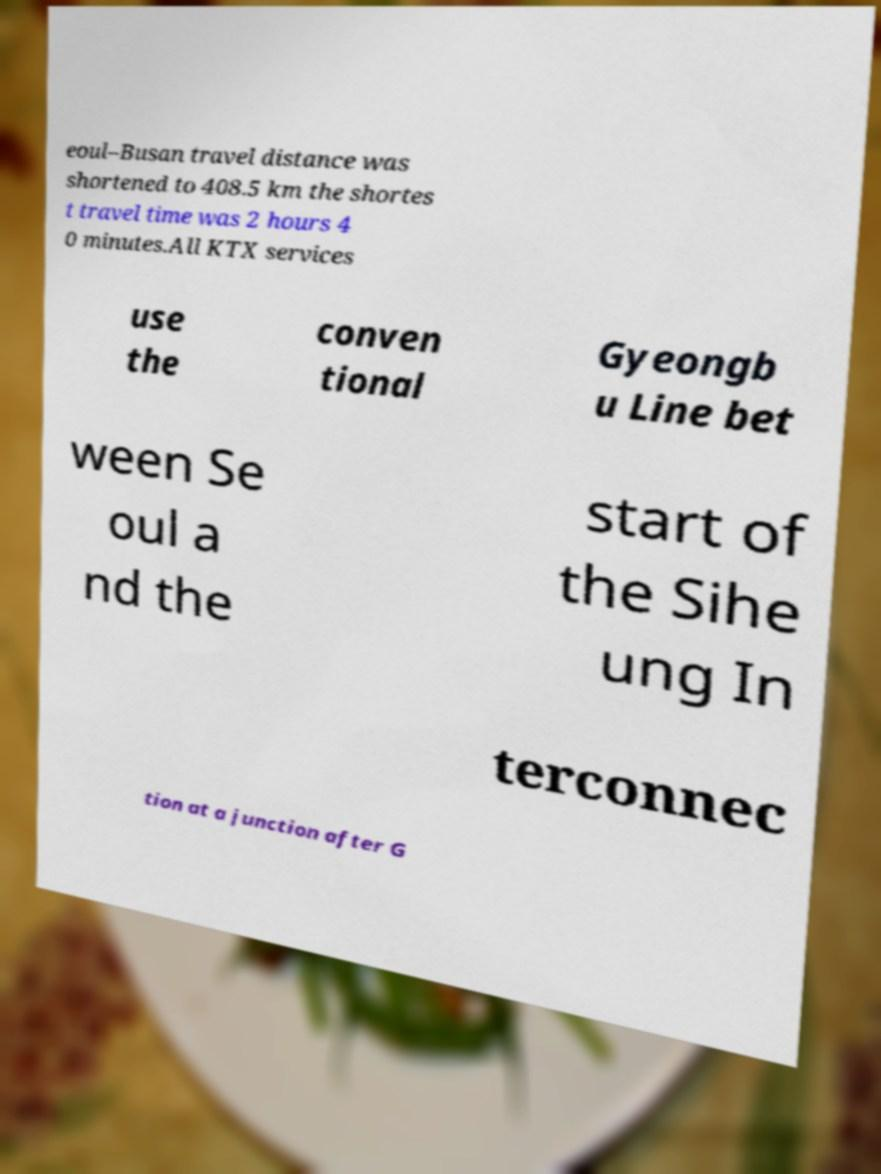Please read and relay the text visible in this image. What does it say? eoul–Busan travel distance was shortened to 408.5 km the shortes t travel time was 2 hours 4 0 minutes.All KTX services use the conven tional Gyeongb u Line bet ween Se oul a nd the start of the Sihe ung In terconnec tion at a junction after G 